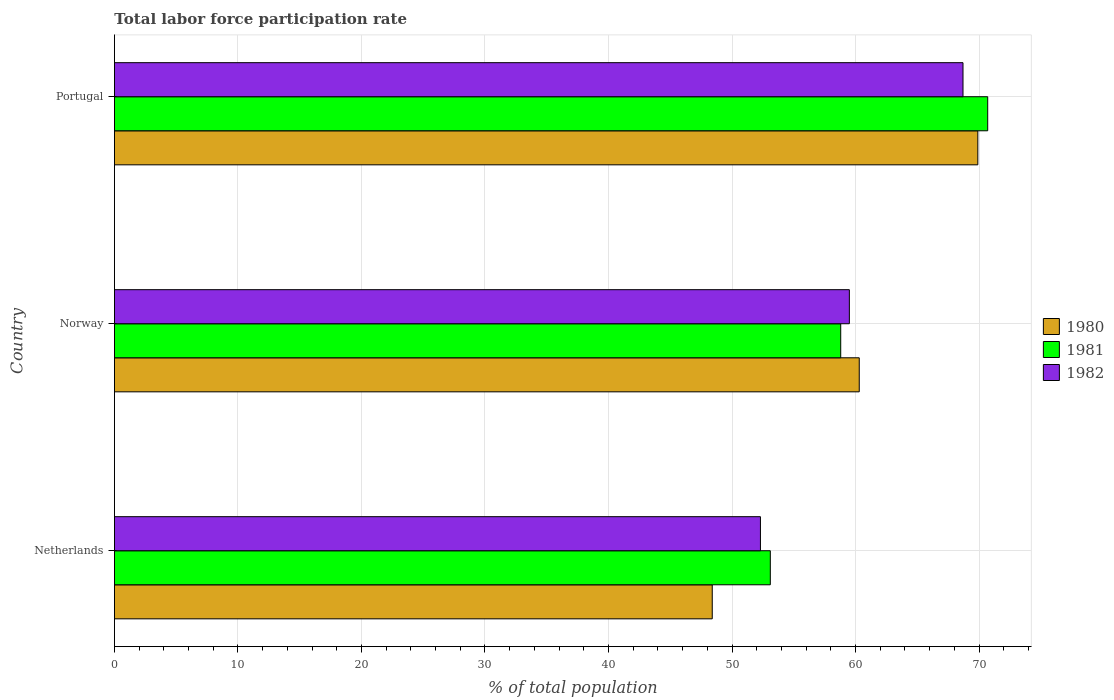Are the number of bars per tick equal to the number of legend labels?
Offer a very short reply. Yes. Are the number of bars on each tick of the Y-axis equal?
Offer a terse response. Yes. How many bars are there on the 1st tick from the top?
Keep it short and to the point. 3. How many bars are there on the 2nd tick from the bottom?
Provide a succinct answer. 3. What is the total labor force participation rate in 1982 in Netherlands?
Provide a succinct answer. 52.3. Across all countries, what is the maximum total labor force participation rate in 1980?
Your response must be concise. 69.9. Across all countries, what is the minimum total labor force participation rate in 1980?
Offer a very short reply. 48.4. In which country was the total labor force participation rate in 1981 minimum?
Give a very brief answer. Netherlands. What is the total total labor force participation rate in 1982 in the graph?
Your response must be concise. 180.5. What is the difference between the total labor force participation rate in 1980 in Netherlands and that in Portugal?
Offer a terse response. -21.5. What is the difference between the total labor force participation rate in 1982 in Norway and the total labor force participation rate in 1981 in Portugal?
Give a very brief answer. -11.2. What is the average total labor force participation rate in 1981 per country?
Give a very brief answer. 60.87. What is the difference between the total labor force participation rate in 1981 and total labor force participation rate in 1980 in Netherlands?
Ensure brevity in your answer.  4.7. What is the ratio of the total labor force participation rate in 1982 in Norway to that in Portugal?
Provide a succinct answer. 0.87. Is the total labor force participation rate in 1981 in Norway less than that in Portugal?
Ensure brevity in your answer.  Yes. What is the difference between the highest and the second highest total labor force participation rate in 1980?
Make the answer very short. 9.6. What is the difference between the highest and the lowest total labor force participation rate in 1981?
Offer a very short reply. 17.6. Is the sum of the total labor force participation rate in 1982 in Netherlands and Norway greater than the maximum total labor force participation rate in 1980 across all countries?
Offer a very short reply. Yes. What does the 2nd bar from the bottom in Portugal represents?
Provide a short and direct response. 1981. Are all the bars in the graph horizontal?
Ensure brevity in your answer.  Yes. How many countries are there in the graph?
Offer a terse response. 3. Does the graph contain any zero values?
Make the answer very short. No. Where does the legend appear in the graph?
Give a very brief answer. Center right. How are the legend labels stacked?
Keep it short and to the point. Vertical. What is the title of the graph?
Offer a terse response. Total labor force participation rate. What is the label or title of the X-axis?
Ensure brevity in your answer.  % of total population. What is the % of total population of 1980 in Netherlands?
Your answer should be very brief. 48.4. What is the % of total population of 1981 in Netherlands?
Your response must be concise. 53.1. What is the % of total population of 1982 in Netherlands?
Provide a short and direct response. 52.3. What is the % of total population of 1980 in Norway?
Your response must be concise. 60.3. What is the % of total population in 1981 in Norway?
Keep it short and to the point. 58.8. What is the % of total population in 1982 in Norway?
Give a very brief answer. 59.5. What is the % of total population in 1980 in Portugal?
Provide a succinct answer. 69.9. What is the % of total population in 1981 in Portugal?
Give a very brief answer. 70.7. What is the % of total population in 1982 in Portugal?
Your answer should be very brief. 68.7. Across all countries, what is the maximum % of total population in 1980?
Your answer should be compact. 69.9. Across all countries, what is the maximum % of total population in 1981?
Your response must be concise. 70.7. Across all countries, what is the maximum % of total population of 1982?
Provide a succinct answer. 68.7. Across all countries, what is the minimum % of total population of 1980?
Your response must be concise. 48.4. Across all countries, what is the minimum % of total population of 1981?
Provide a short and direct response. 53.1. Across all countries, what is the minimum % of total population of 1982?
Your answer should be compact. 52.3. What is the total % of total population in 1980 in the graph?
Offer a very short reply. 178.6. What is the total % of total population of 1981 in the graph?
Offer a terse response. 182.6. What is the total % of total population in 1982 in the graph?
Offer a terse response. 180.5. What is the difference between the % of total population in 1980 in Netherlands and that in Portugal?
Your answer should be very brief. -21.5. What is the difference between the % of total population of 1981 in Netherlands and that in Portugal?
Provide a short and direct response. -17.6. What is the difference between the % of total population of 1982 in Netherlands and that in Portugal?
Offer a terse response. -16.4. What is the difference between the % of total population of 1980 in Norway and that in Portugal?
Ensure brevity in your answer.  -9.6. What is the difference between the % of total population in 1981 in Norway and that in Portugal?
Your answer should be compact. -11.9. What is the difference between the % of total population of 1981 in Netherlands and the % of total population of 1982 in Norway?
Ensure brevity in your answer.  -6.4. What is the difference between the % of total population in 1980 in Netherlands and the % of total population in 1981 in Portugal?
Your answer should be compact. -22.3. What is the difference between the % of total population in 1980 in Netherlands and the % of total population in 1982 in Portugal?
Provide a succinct answer. -20.3. What is the difference between the % of total population in 1981 in Netherlands and the % of total population in 1982 in Portugal?
Make the answer very short. -15.6. What is the difference between the % of total population in 1980 in Norway and the % of total population in 1982 in Portugal?
Give a very brief answer. -8.4. What is the average % of total population in 1980 per country?
Your answer should be very brief. 59.53. What is the average % of total population of 1981 per country?
Ensure brevity in your answer.  60.87. What is the average % of total population of 1982 per country?
Provide a short and direct response. 60.17. What is the difference between the % of total population of 1980 and % of total population of 1981 in Norway?
Offer a very short reply. 1.5. What is the difference between the % of total population in 1980 and % of total population in 1982 in Norway?
Give a very brief answer. 0.8. What is the difference between the % of total population in 1980 and % of total population in 1981 in Portugal?
Provide a short and direct response. -0.8. What is the difference between the % of total population in 1981 and % of total population in 1982 in Portugal?
Provide a succinct answer. 2. What is the ratio of the % of total population in 1980 in Netherlands to that in Norway?
Give a very brief answer. 0.8. What is the ratio of the % of total population of 1981 in Netherlands to that in Norway?
Give a very brief answer. 0.9. What is the ratio of the % of total population in 1982 in Netherlands to that in Norway?
Offer a very short reply. 0.88. What is the ratio of the % of total population in 1980 in Netherlands to that in Portugal?
Offer a terse response. 0.69. What is the ratio of the % of total population of 1981 in Netherlands to that in Portugal?
Your answer should be very brief. 0.75. What is the ratio of the % of total population in 1982 in Netherlands to that in Portugal?
Keep it short and to the point. 0.76. What is the ratio of the % of total population of 1980 in Norway to that in Portugal?
Ensure brevity in your answer.  0.86. What is the ratio of the % of total population in 1981 in Norway to that in Portugal?
Your answer should be very brief. 0.83. What is the ratio of the % of total population in 1982 in Norway to that in Portugal?
Offer a terse response. 0.87. What is the difference between the highest and the second highest % of total population in 1980?
Offer a terse response. 9.6. What is the difference between the highest and the second highest % of total population of 1982?
Keep it short and to the point. 9.2. What is the difference between the highest and the lowest % of total population in 1980?
Make the answer very short. 21.5. What is the difference between the highest and the lowest % of total population of 1981?
Give a very brief answer. 17.6. What is the difference between the highest and the lowest % of total population in 1982?
Ensure brevity in your answer.  16.4. 